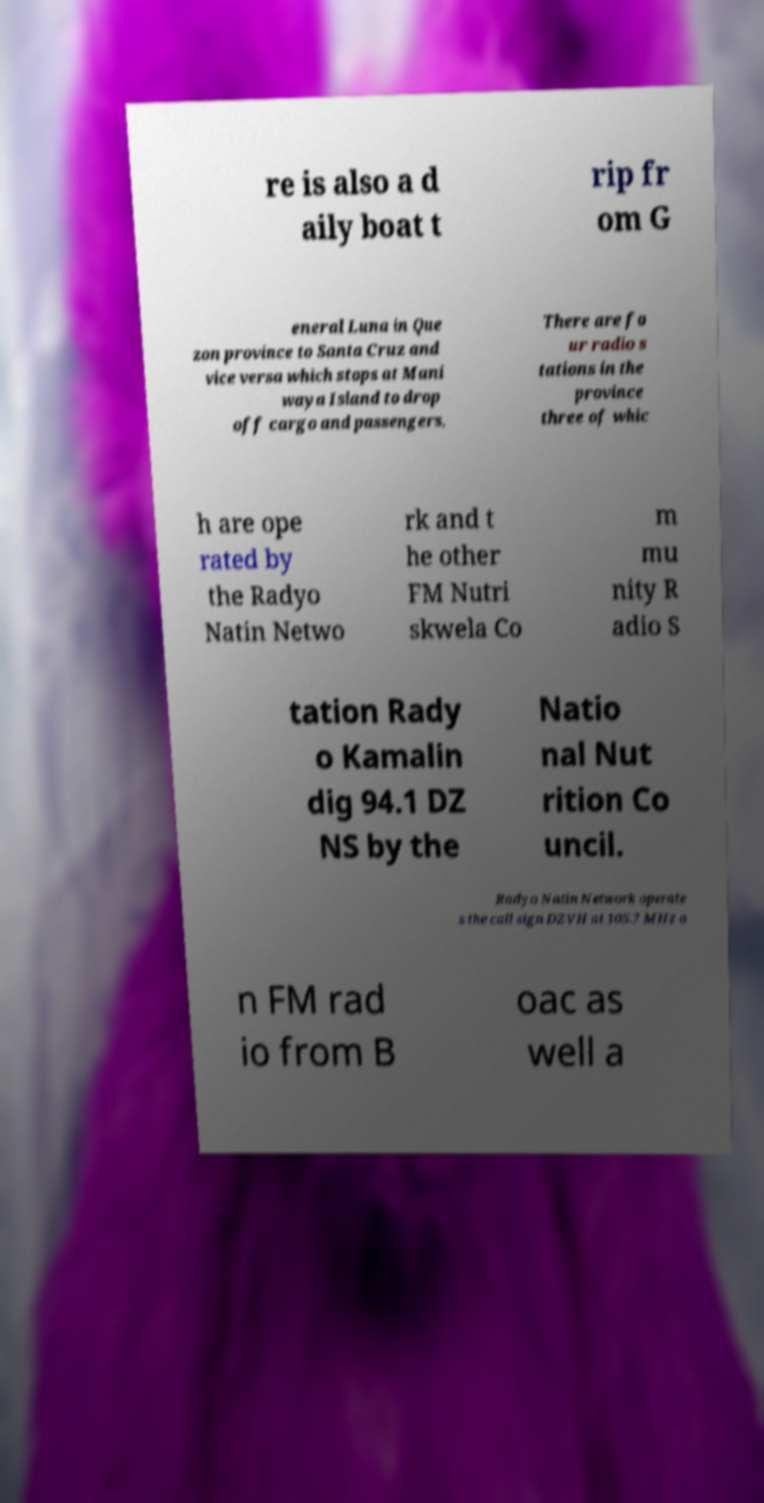What messages or text are displayed in this image? I need them in a readable, typed format. re is also a d aily boat t rip fr om G eneral Luna in Que zon province to Santa Cruz and vice versa which stops at Mani waya Island to drop off cargo and passengers. There are fo ur radio s tations in the province three of whic h are ope rated by the Radyo Natin Netwo rk and t he other FM Nutri skwela Co m mu nity R adio S tation Rady o Kamalin dig 94.1 DZ NS by the Natio nal Nut rition Co uncil. Radyo Natin Network operate s the call sign DZVH at 105.7 MHz o n FM rad io from B oac as well a 